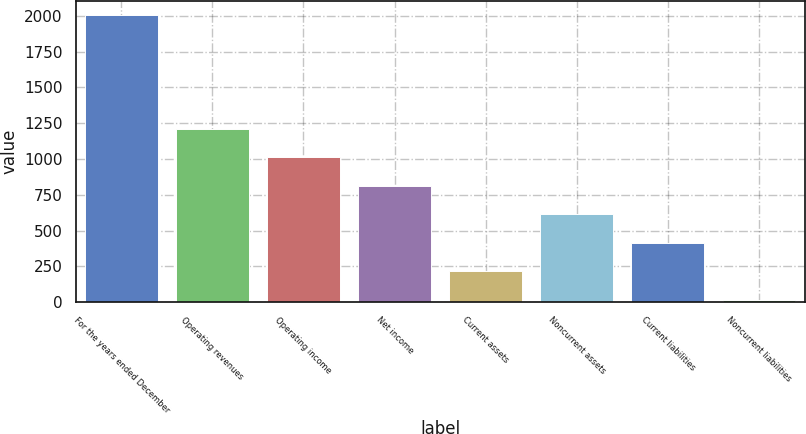Convert chart. <chart><loc_0><loc_0><loc_500><loc_500><bar_chart><fcel>For the years ended December<fcel>Operating revenues<fcel>Operating income<fcel>Net income<fcel>Current assets<fcel>Noncurrent assets<fcel>Current liabilities<fcel>Noncurrent liabilities<nl><fcel>2006<fcel>1210.4<fcel>1011.5<fcel>812.6<fcel>215.9<fcel>613.7<fcel>414.8<fcel>17<nl></chart> 